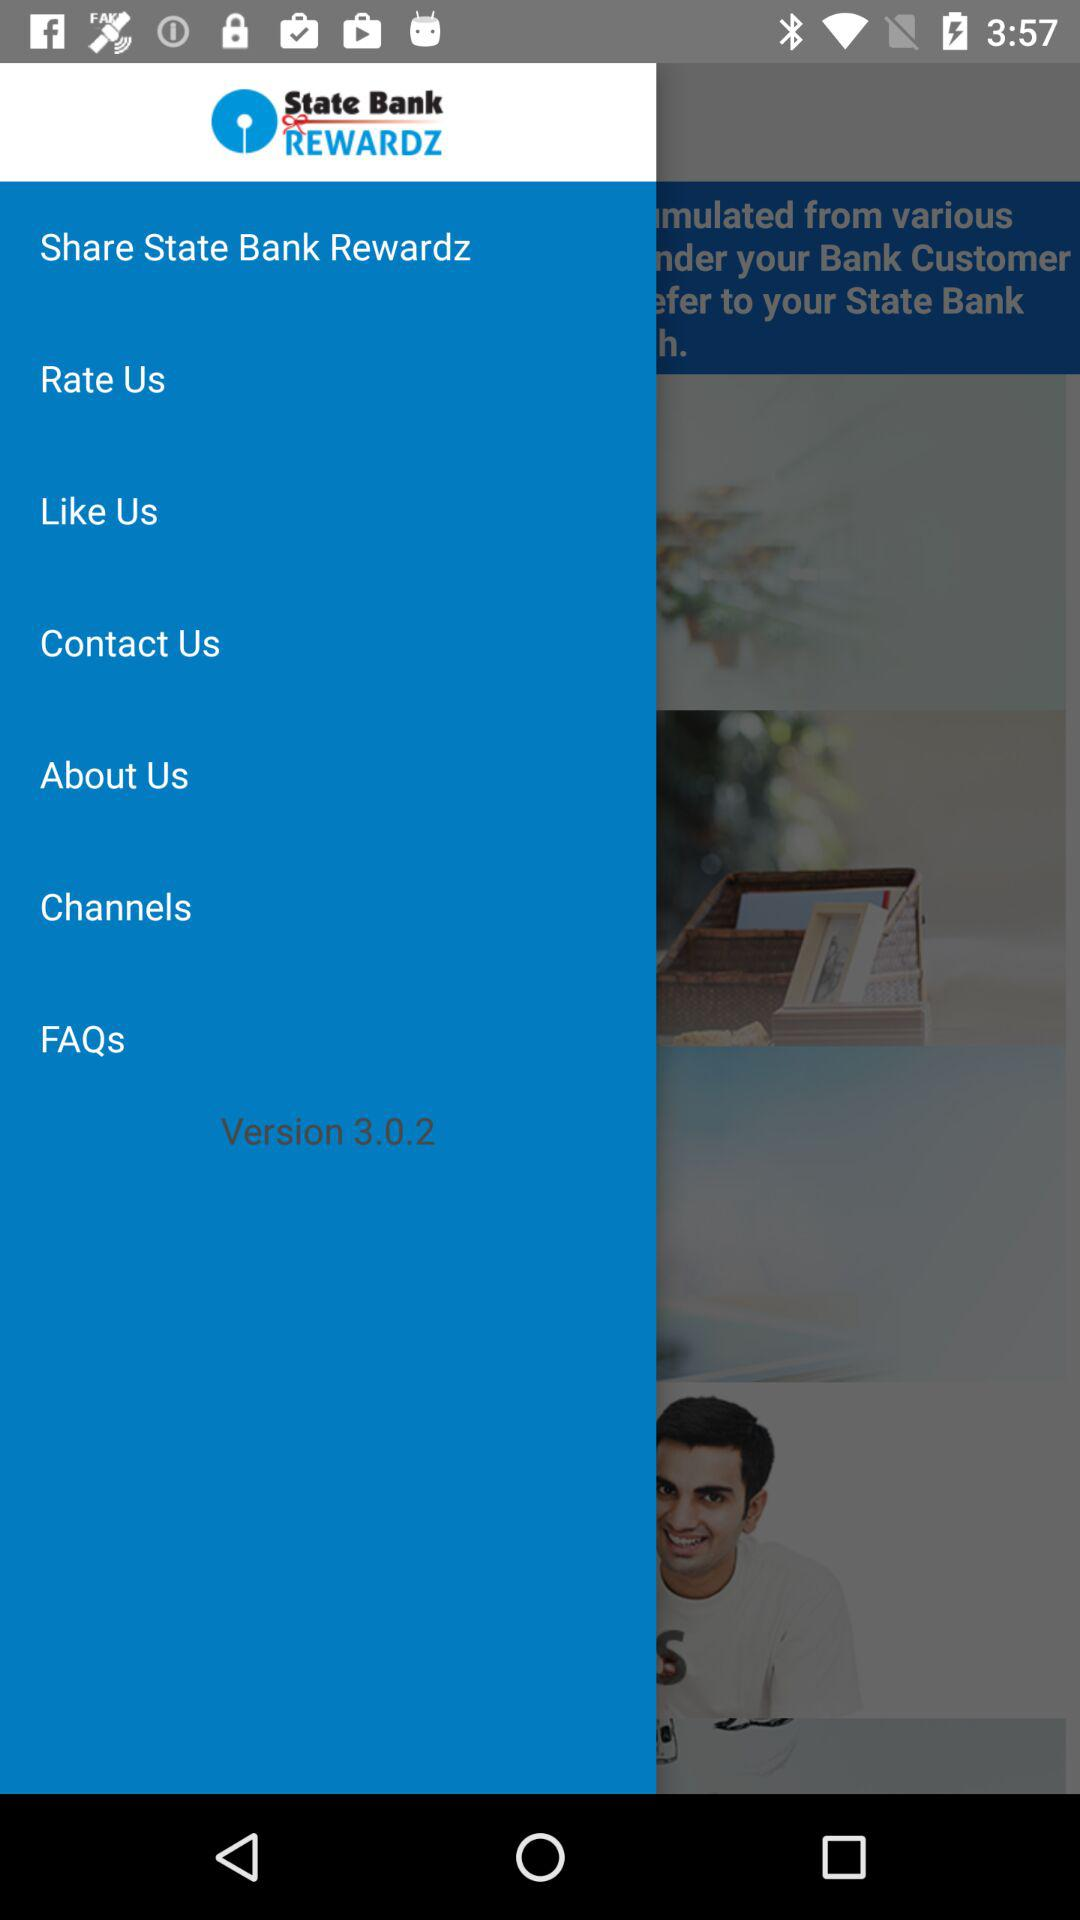What is the version of the application? The version is 3.0.2. 